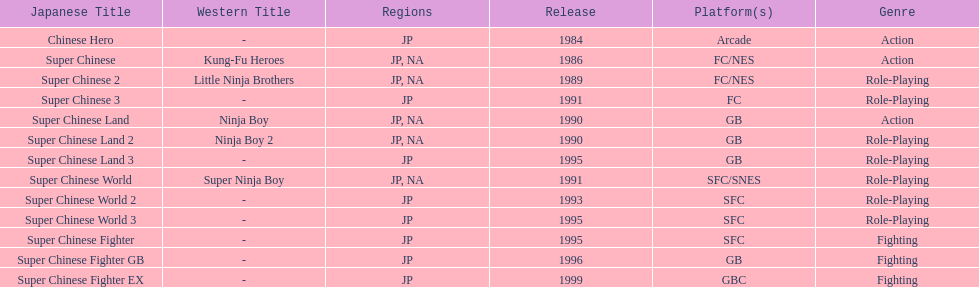Among the titles introduced in north america, which had the lowest number of releases? Super Chinese World. 